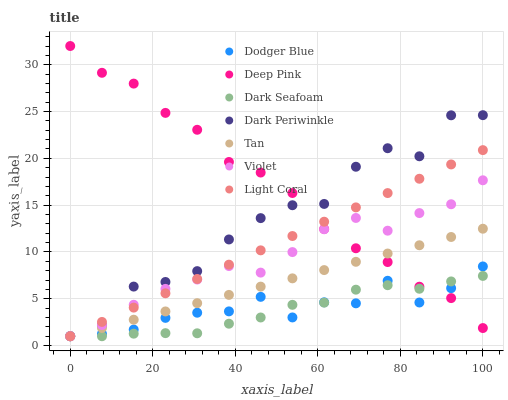Does Dark Seafoam have the minimum area under the curve?
Answer yes or no. Yes. Does Deep Pink have the maximum area under the curve?
Answer yes or no. Yes. Does Light Coral have the minimum area under the curve?
Answer yes or no. No. Does Light Coral have the maximum area under the curve?
Answer yes or no. No. Is Tan the smoothest?
Answer yes or no. Yes. Is Dark Periwinkle the roughest?
Answer yes or no. Yes. Is Light Coral the smoothest?
Answer yes or no. No. Is Light Coral the roughest?
Answer yes or no. No. Does Light Coral have the lowest value?
Answer yes or no. Yes. Does Dodger Blue have the lowest value?
Answer yes or no. No. Does Deep Pink have the highest value?
Answer yes or no. Yes. Does Light Coral have the highest value?
Answer yes or no. No. Does Tan intersect Dark Periwinkle?
Answer yes or no. Yes. Is Tan less than Dark Periwinkle?
Answer yes or no. No. Is Tan greater than Dark Periwinkle?
Answer yes or no. No. 